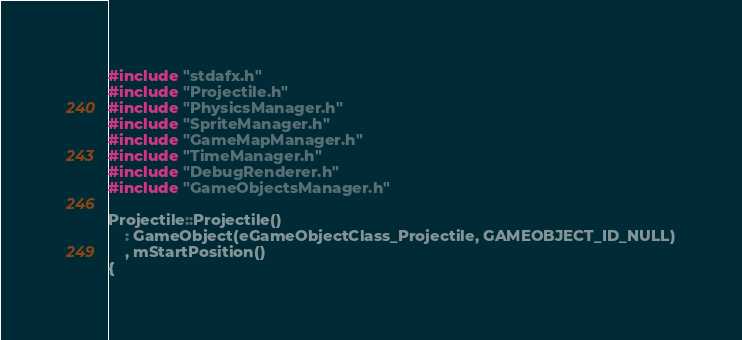<code> <loc_0><loc_0><loc_500><loc_500><_C++_>#include "stdafx.h"
#include "Projectile.h"
#include "PhysicsManager.h"
#include "SpriteManager.h"
#include "GameMapManager.h"
#include "TimeManager.h"
#include "DebugRenderer.h"
#include "GameObjectsManager.h"

Projectile::Projectile() 
    : GameObject(eGameObjectClass_Projectile, GAMEOBJECT_ID_NULL)
    , mStartPosition()
{</code> 